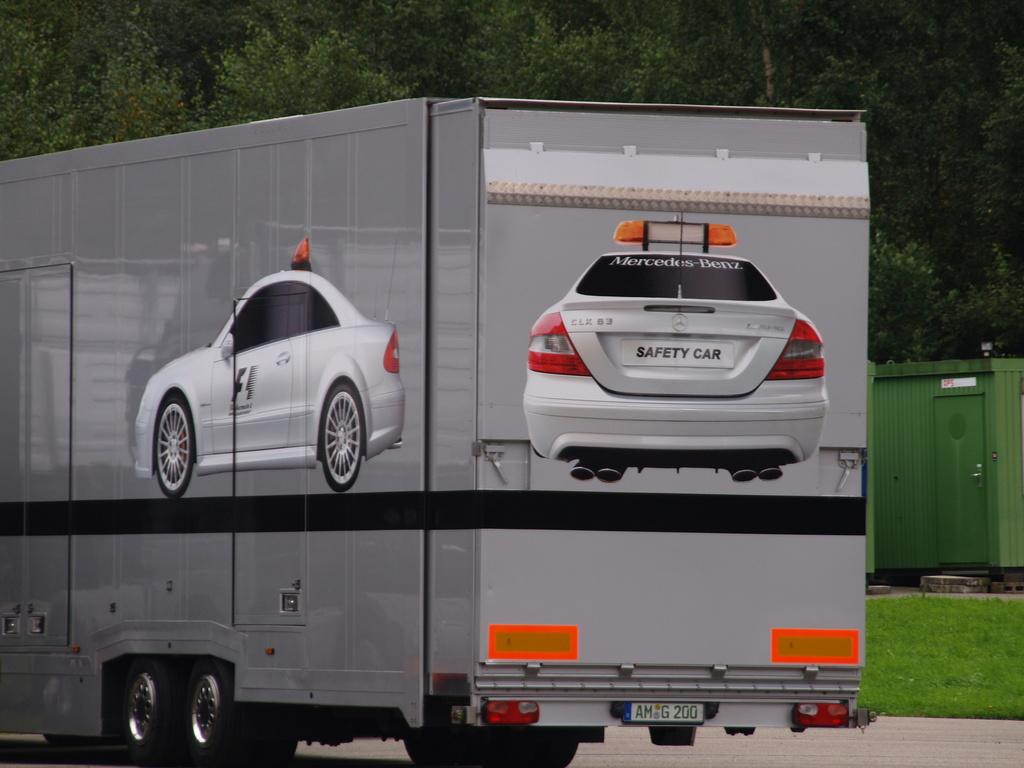What type of vegetation can be seen in the image? There are trees in the image. What else can be found in the image besides trees? There is a small garden in the image. What vehicle is present in the image? There is a truck in the image. Can you describe the truck's appearance? The truck has two car images drawn on it. What is the purpose of the door visible in the image? The door's purpose is not specified, but it is visible in the image. How many cherries are hanging from the trees in the image? There is no mention of cherries in the image; only trees are mentioned. How many children are playing in the garden in the image? There is no mention of children in the image; only a small garden is mentioned. 